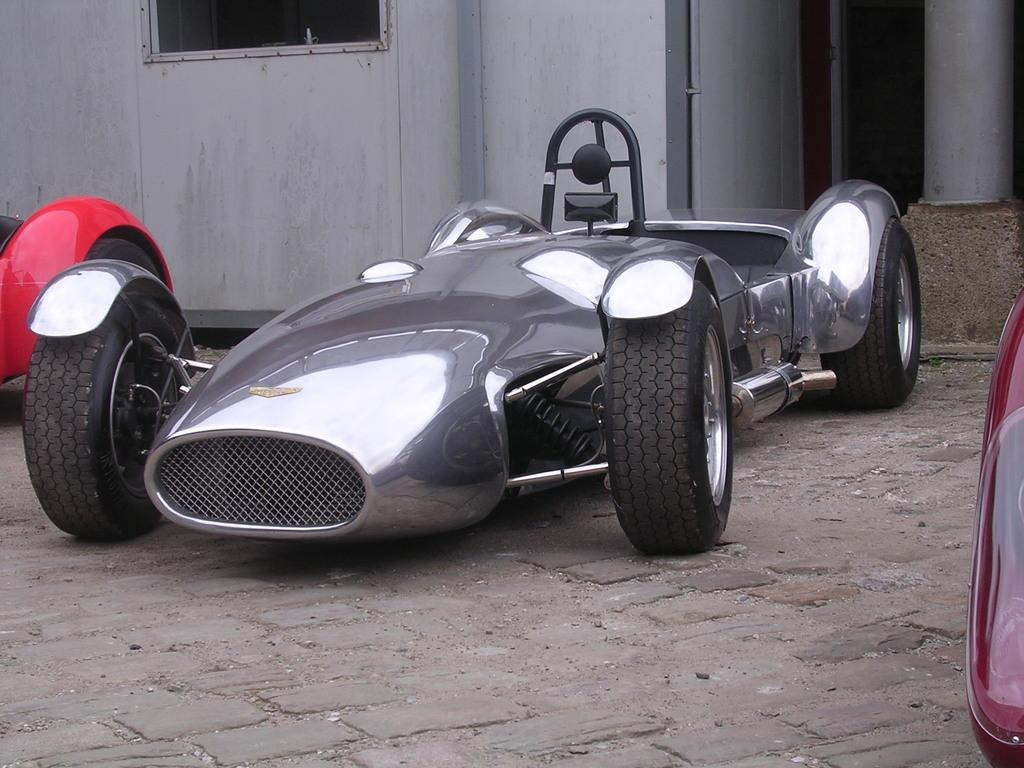What type of vehicles can be seen in the image? There are cars on the road in the image. Where are the cars located in relation to the building? The cars are in front of a building. What type of cough can be heard coming from the building in the image? There is no indication of a cough or any sound in the image, so it cannot be determined from the picture. 